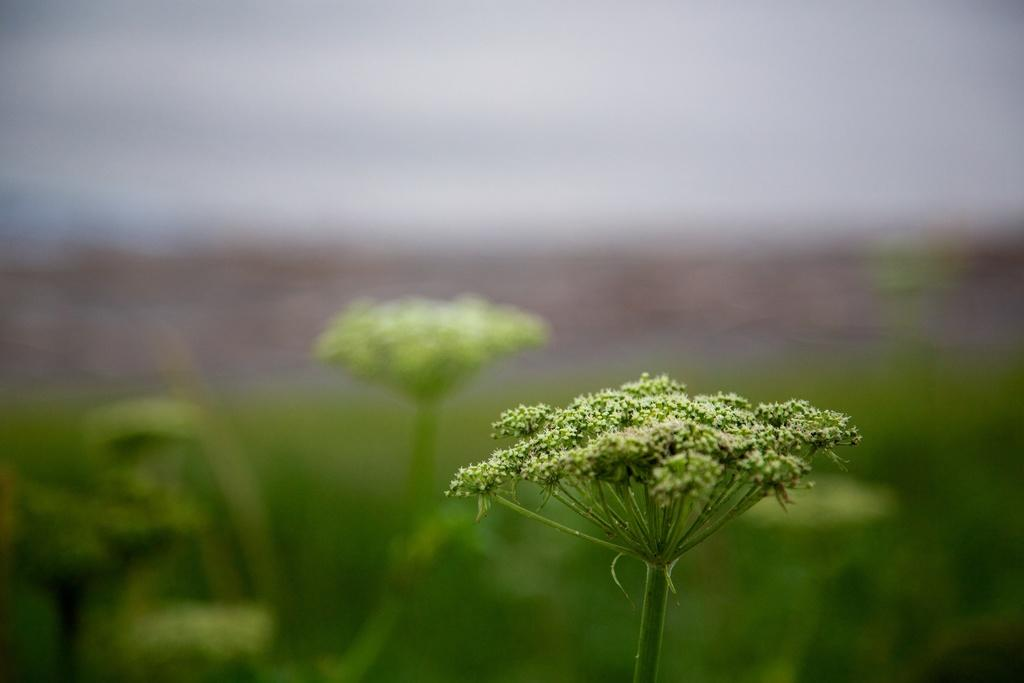What is present in the image? There is a plant in the image. Can you describe the appearance of the plant in the image? The plant appears to be in front of an illusion of other plants in the image. What type of home does the plant belong to in the image? The image does not provide information about the plant belonging to a home. What achievements has the plant accomplished in the image? The image does not provide information about the plant's achievements. 